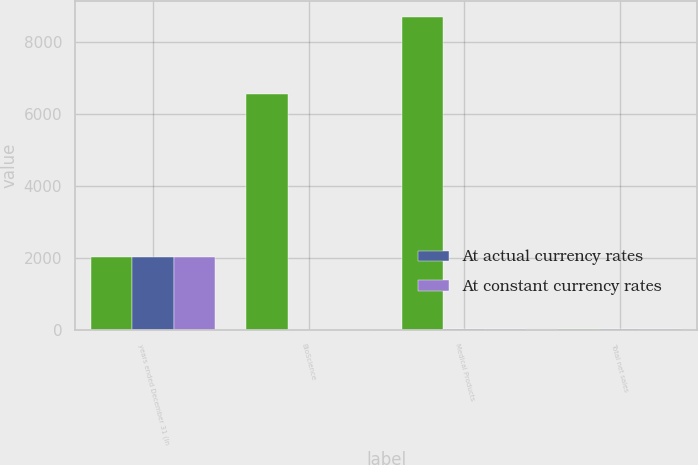Convert chart. <chart><loc_0><loc_0><loc_500><loc_500><stacked_bar_chart><ecel><fcel>years ended December 31 (in<fcel>BioScience<fcel>Medical Products<fcel>Total net sales<nl><fcel>nan<fcel>2013<fcel>6564<fcel>8695<fcel>10<nl><fcel>At actual currency rates<fcel>2013<fcel>5<fcel>9<fcel>8<nl><fcel>At constant currency rates<fcel>2013<fcel>6<fcel>10<fcel>8<nl></chart> 